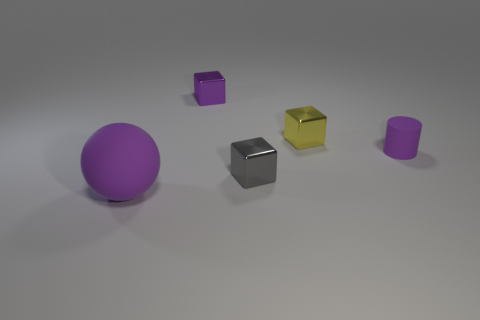There is a purple thing in front of the tiny gray block; what is its size?
Ensure brevity in your answer.  Large. What material is the purple cylinder that is the same size as the yellow metal block?
Offer a terse response. Rubber. What number of other objects are there of the same material as the large object?
Your answer should be very brief. 1. There is a small purple object that is left of the yellow shiny object; does it have the same shape as the small thing that is in front of the purple cylinder?
Offer a terse response. Yes. How many other things are there of the same color as the tiny rubber object?
Offer a very short reply. 2. Are the object that is in front of the small gray metal thing and the purple object right of the tiny gray block made of the same material?
Your answer should be compact. Yes. Are there the same number of spheres to the left of the big purple rubber object and big purple spheres in front of the purple shiny thing?
Offer a very short reply. No. What material is the purple thing that is behind the yellow metallic block?
Ensure brevity in your answer.  Metal. Is there any other thing that is the same size as the matte sphere?
Offer a very short reply. No. Are there fewer purple matte objects than tiny shiny things?
Make the answer very short. Yes. 